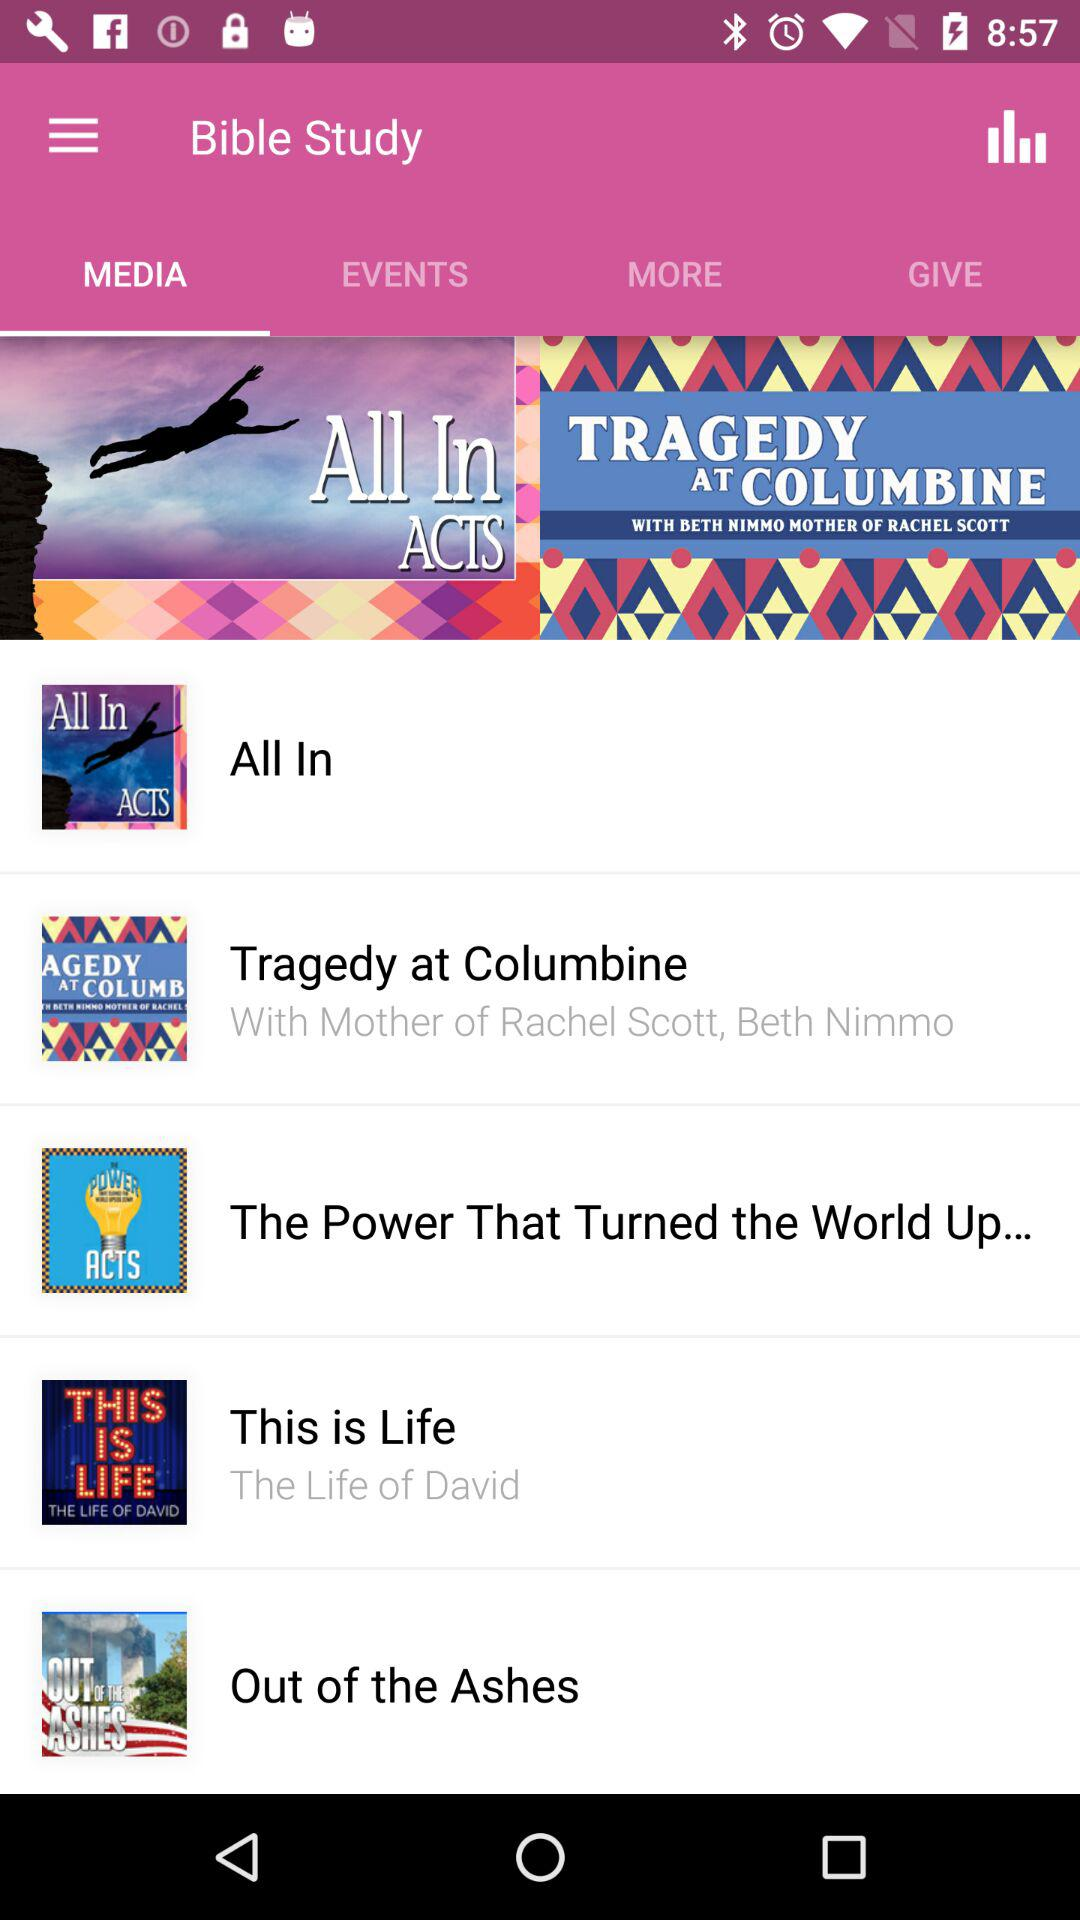What is the name of the application? The name of the application is "Bible Study". 